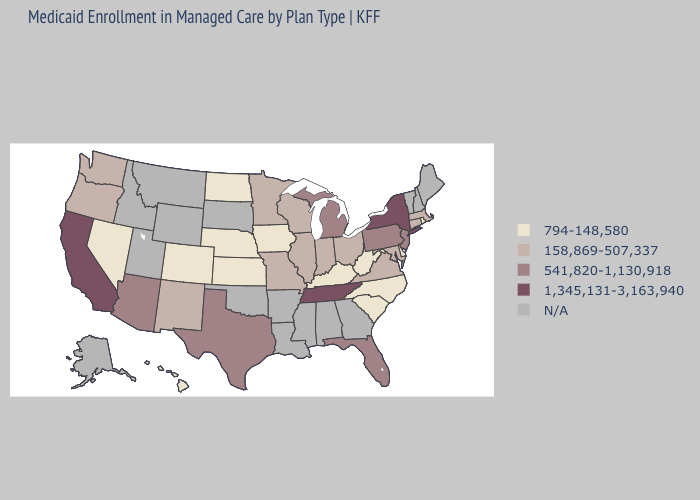Name the states that have a value in the range 1,345,131-3,163,940?
Short answer required. California, New York, Tennessee. Name the states that have a value in the range 1,345,131-3,163,940?
Give a very brief answer. California, New York, Tennessee. Which states hav the highest value in the West?
Short answer required. California. How many symbols are there in the legend?
Give a very brief answer. 5. Name the states that have a value in the range N/A?
Be succinct. Alabama, Alaska, Arkansas, Georgia, Idaho, Louisiana, Maine, Mississippi, Montana, New Hampshire, Oklahoma, South Dakota, Utah, Vermont, Wyoming. What is the value of Oklahoma?
Quick response, please. N/A. How many symbols are there in the legend?
Give a very brief answer. 5. What is the lowest value in states that border Kentucky?
Give a very brief answer. 794-148,580. What is the value of Montana?
Answer briefly. N/A. Name the states that have a value in the range 1,345,131-3,163,940?
Short answer required. California, New York, Tennessee. Name the states that have a value in the range 541,820-1,130,918?
Short answer required. Arizona, Florida, Michigan, New Jersey, Pennsylvania, Texas. 